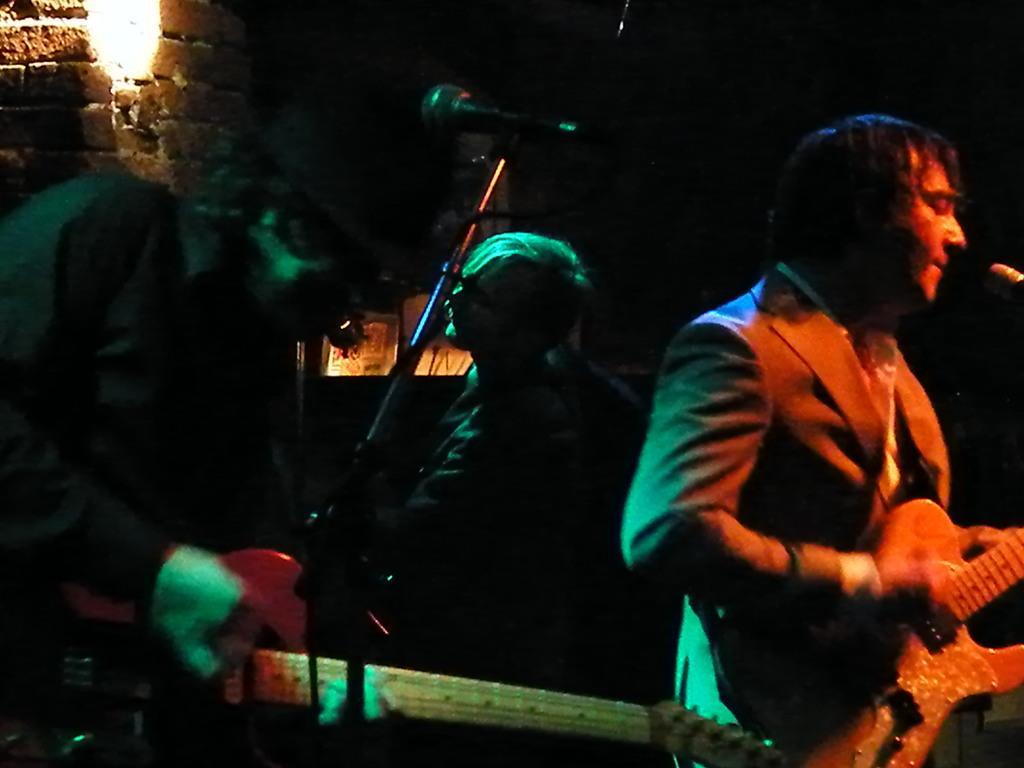Describe this image in one or two sentences. In the image there are three people standing and playing their musical instruments in front of a microphone, in background there is a brick wall and a light. 